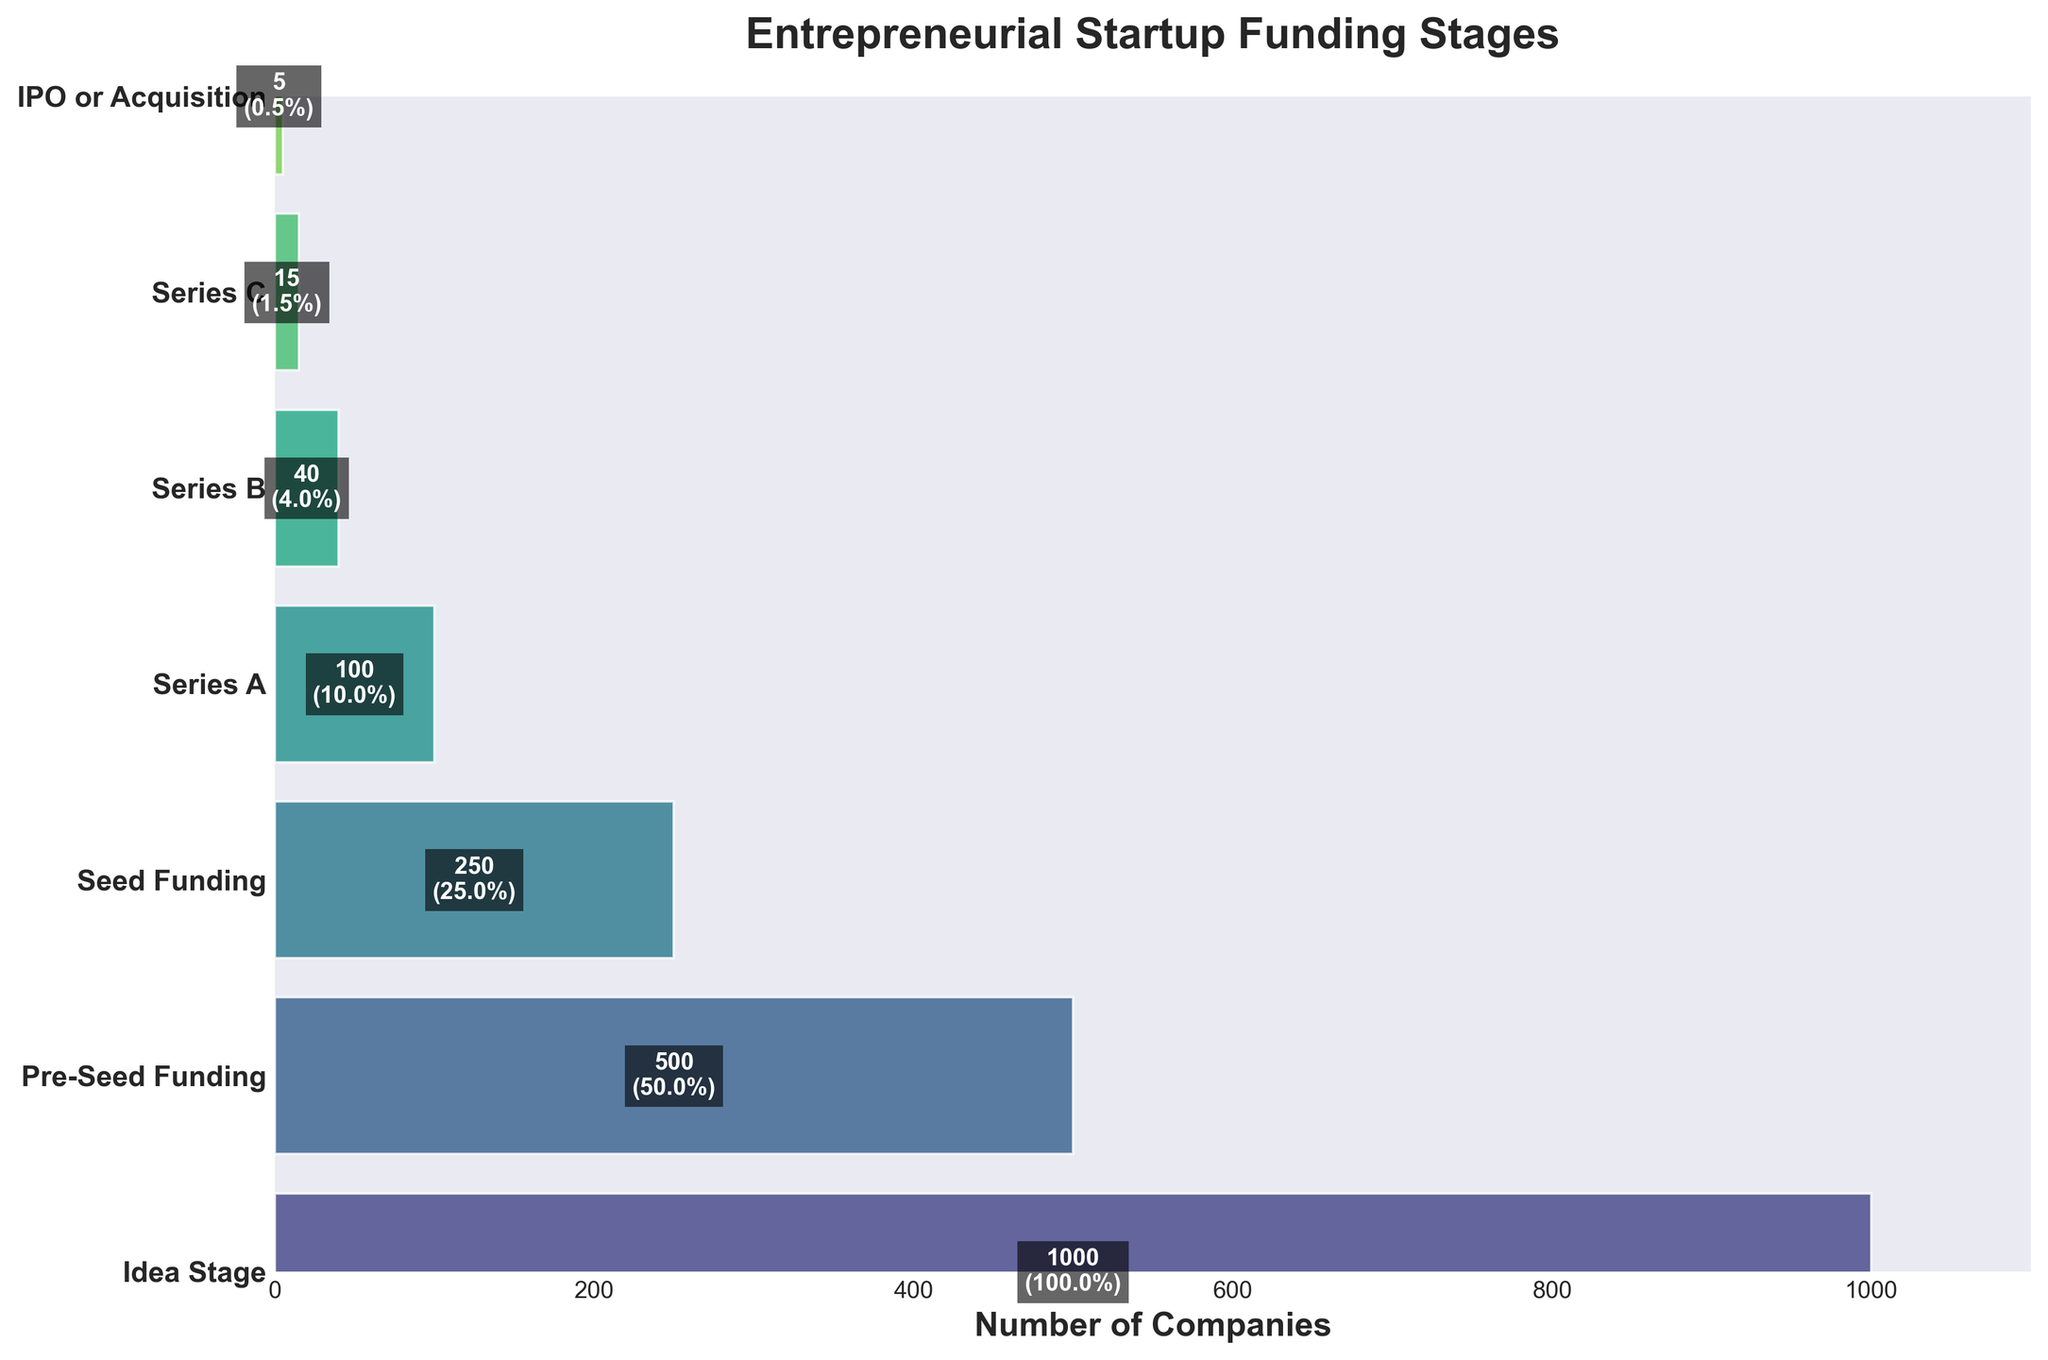How many companies reach the Series A stage? The number of companies that reach the Series A stage is indicated on the corresponding bar in the funnel chart.
Answer: 100 Which stage has the highest success rate? The stage with the highest success rate is shown at the top of the funnel chart, with a success rate close to 100%. This is the Idea Stage.
Answer: Idea Stage What is the decrease in the number of companies between Seed Funding and Series A? To find the decrease, subtract the number of companies in Series A from the number of companies in Seed Funding (250 - 100).
Answer: 150 Which stage shows the most significant drop in the success rate compared to the previous stage? By comparing each successive stage, the largest drop in the success rate occurs between Seed Funding (25%) and Series A (10%).
Answer: Seed Funding to Series A What proportion of companies make it from the Pre-Seed Funding to the Seed Funding stage? The proportion is found by dividing the number of companies in Seed Funding by the number of companies in Pre-Seed Funding (250/500), which gives 50%.
Answer: 50% What is the total number of companies at the Idea Stage and Pre-Seed Funding stage combined? Add the number of companies at the Idea Stage (1000) and Pre-Seed Funding stage (500).
Answer: 1500 How many stages are depicted in the funnel chart? Count the distinct stages listed on the y-axis of the funnel chart.
Answer: 7 Which stage has the fewest number of companies? The fewest number of companies is shown at the bottom of the funnel chart. This is the IPO or Acquisition stage with 5 companies.
Answer: IPO or Acquisition What is the success rate at the Series C stage? The success rate at the Series C stage is indicated on the bar for Series C as 1.5%.
Answer: 1.5% How does the width of the bar representing Series B compare to the width of the bar representing Series A? The width of the bar for Series B (40 companies) is narrower than that for Series A (100 companies). This shows a decrease from Series A to Series B.
Answer: Series B is narrower than Series A 